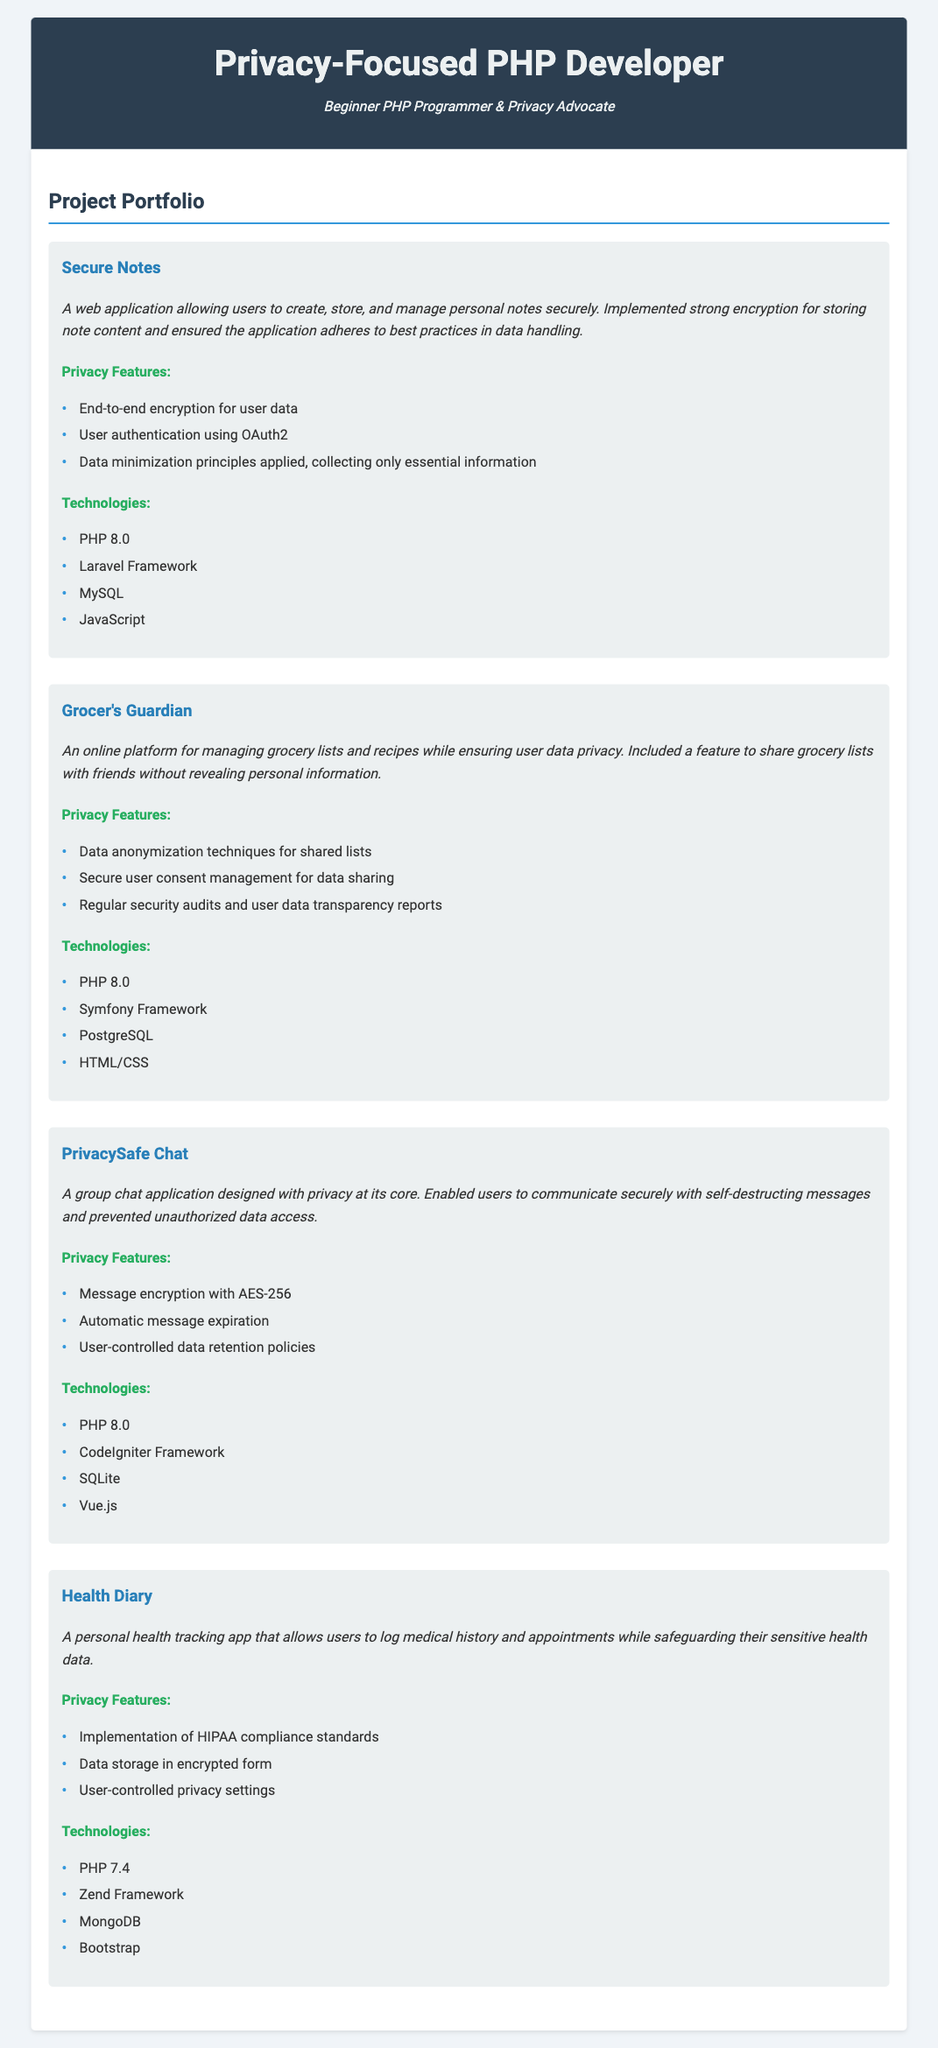What is the title of the portfolio? The title is the main heading of the resume that identifies the individual’s professional focus.
Answer: Privacy-Focused PHP Developer How many projects are listed in the portfolio? The total count of distinct projects mentioned in the portfolio reflects the developer's experience.
Answer: Four What technology is used in the Secure Notes project? The technologies section for each project lists the tools and frameworks employed, including PHP and frameworks.
Answer: Laravel Framework What privacy feature is offered in the PrivacySafe Chat application? The privacy features listed for each project indicate specific functionalities designed to protect user data.
Answer: Message encryption with AES-256 Which framework is used in the Health Diary project? Each project includes a section detailing the technologies utilized, including frameworks, databases, and libraries.
Answer: Zend Framework What type of encryption is implemented in Secure Notes? The project descriptions often highlight security measures, showcasing the focus on data protection.
Answer: Strong encryption What principle is applied regarding user data in the Grocer's Guardian? Privacy features often illustrate the adherence to certain standards or principles in managing user data.
Answer: Data minimization principles What is the primary purpose of the Health Diary application? The project descriptions summarize the core functionality of each application designed by the developer.
Answer: Personal health tracking What is the development language used in all projects? The technologies sections consistently list programming languages or frameworks used across projects.
Answer: PHP 8.0 